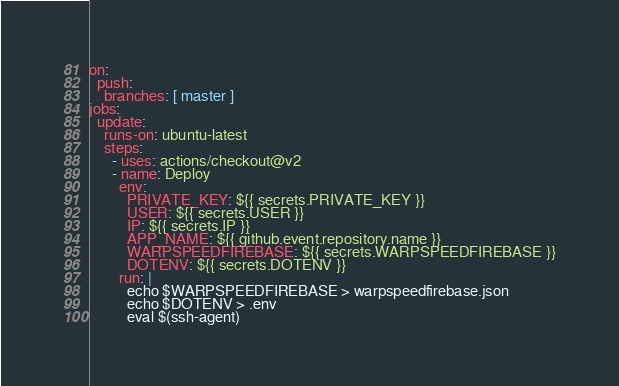Convert code to text. <code><loc_0><loc_0><loc_500><loc_500><_YAML_>on:
  push:
    branches: [ master ]
jobs:
  update:
    runs-on: ubuntu-latest
    steps:
      - uses: actions/checkout@v2
      - name: Deploy
        env:
          PRIVATE_KEY: ${{ secrets.PRIVATE_KEY }}
          USER: ${{ secrets.USER }}
          IP: ${{ secrets.IP }}
          APP_NAME: ${{ github.event.repository.name }}
          WARPSPEEDFIREBASE: ${{ secrets.WARPSPEEDFIREBASE }}
          DOTENV: ${{ secrets.DOTENV }}
        run: |
          echo $WARPSPEEDFIREBASE > warpspeedfirebase.json
          echo $DOTENV > .env
          eval $(ssh-agent)</code> 